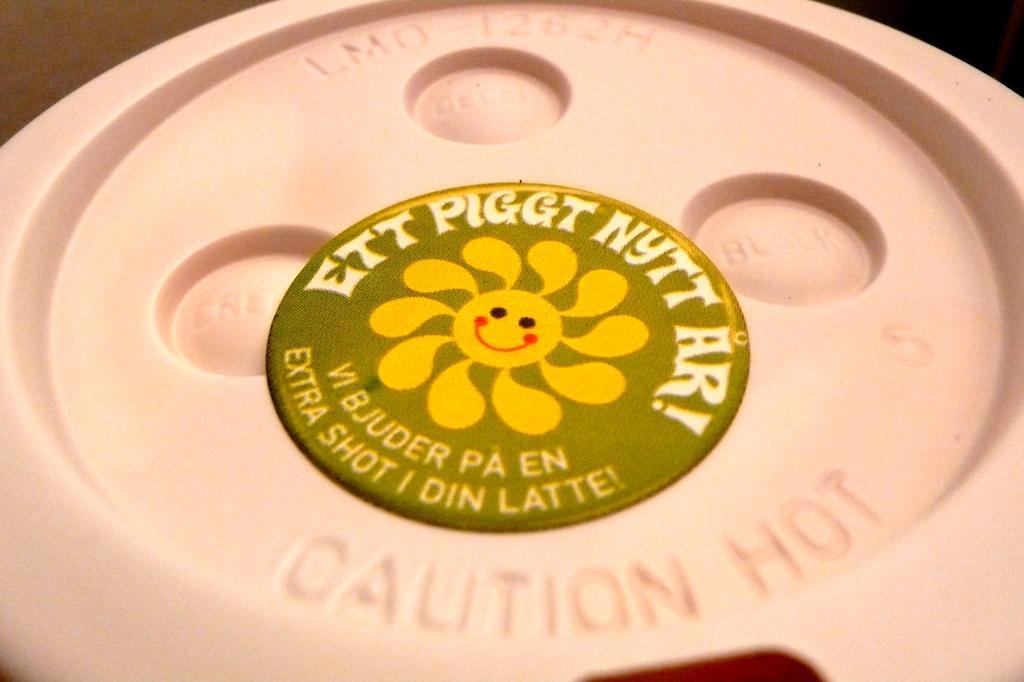Could you give a brief overview of what you see in this image? In this image we can see a label on the object. 